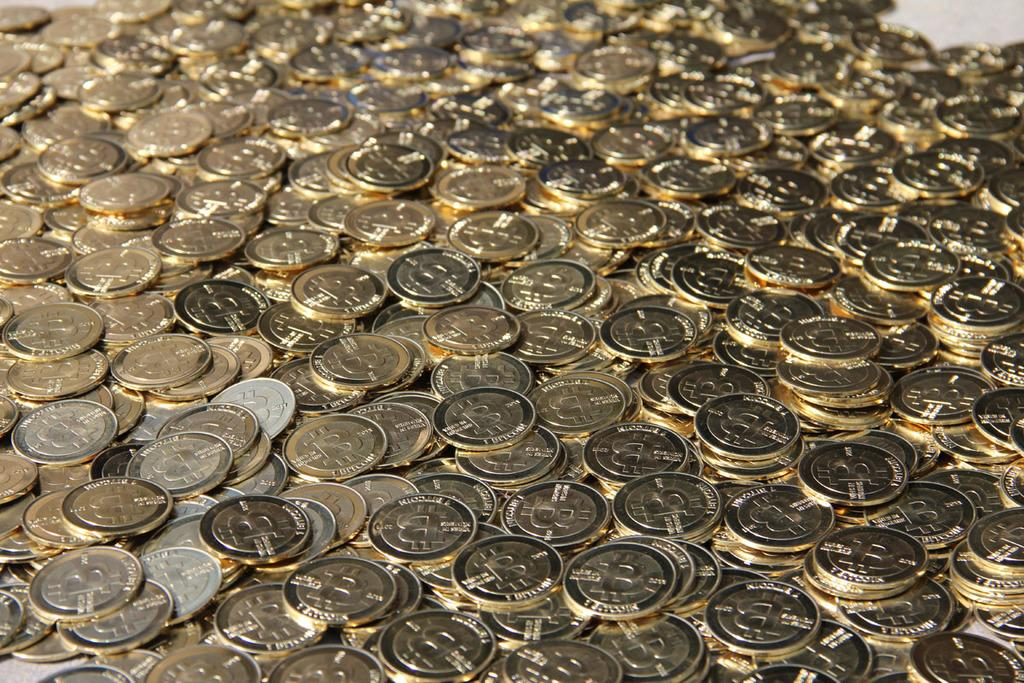What is the main subject of the image? The main subject of the image is a cluster of coins. Can you describe the arrangement of the coins in the image? The coins are clustered together in the image. What type of bag is being used to carry the coins in the image? There is no bag present in the image; it only shows a cluster of coins. Is the person in the image reading a book while holding the coins? There is no person or book present in the image; it only shows a cluster of coins. 